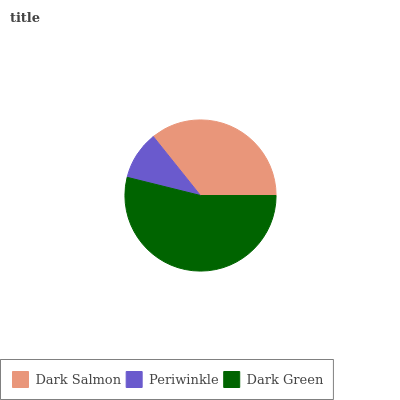Is Periwinkle the minimum?
Answer yes or no. Yes. Is Dark Green the maximum?
Answer yes or no. Yes. Is Dark Green the minimum?
Answer yes or no. No. Is Periwinkle the maximum?
Answer yes or no. No. Is Dark Green greater than Periwinkle?
Answer yes or no. Yes. Is Periwinkle less than Dark Green?
Answer yes or no. Yes. Is Periwinkle greater than Dark Green?
Answer yes or no. No. Is Dark Green less than Periwinkle?
Answer yes or no. No. Is Dark Salmon the high median?
Answer yes or no. Yes. Is Dark Salmon the low median?
Answer yes or no. Yes. Is Dark Green the high median?
Answer yes or no. No. Is Dark Green the low median?
Answer yes or no. No. 